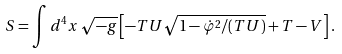Convert formula to latex. <formula><loc_0><loc_0><loc_500><loc_500>S = \int d ^ { 4 } x \, \sqrt { - g } \left [ - T U \sqrt { 1 - \dot { \varphi } ^ { 2 } / ( T U ) } + T - V \right ] .</formula> 